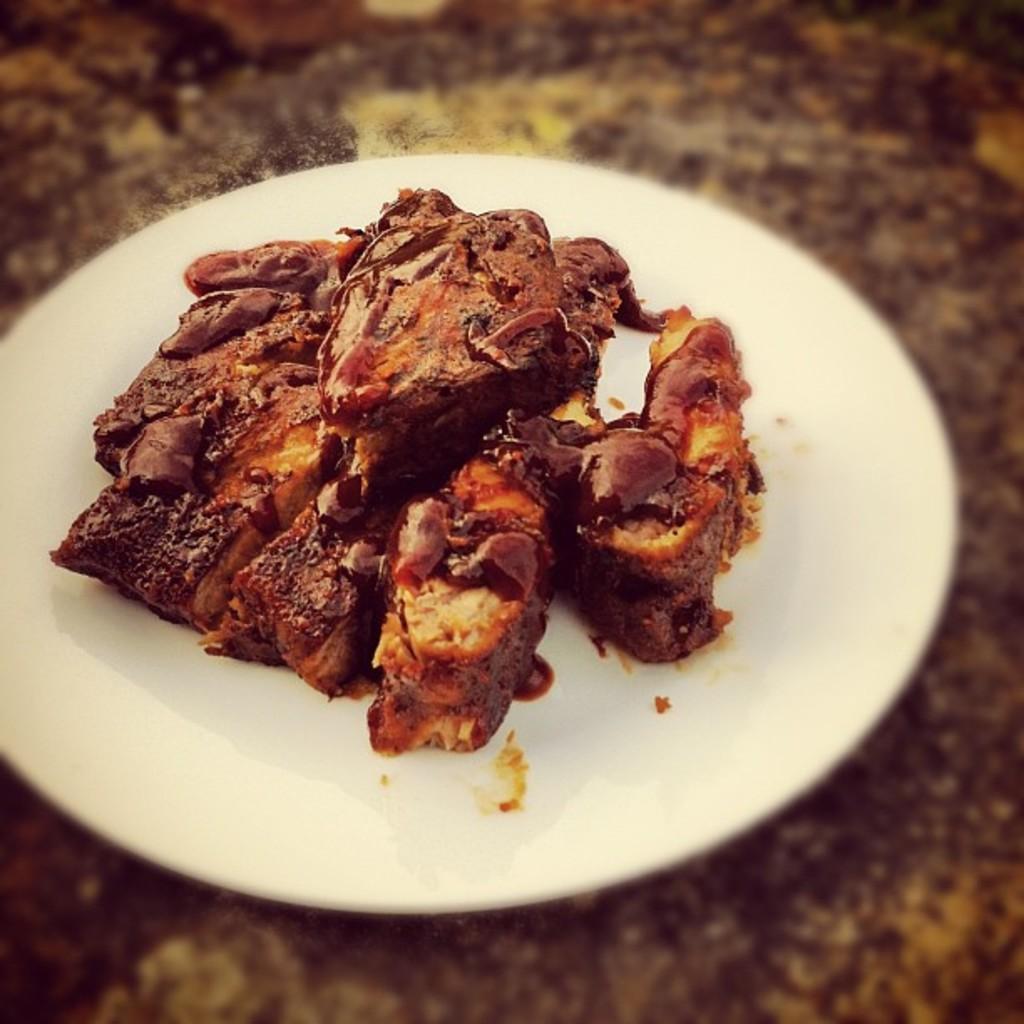Describe this image in one or two sentences. In this picture we can see food in the plate. 